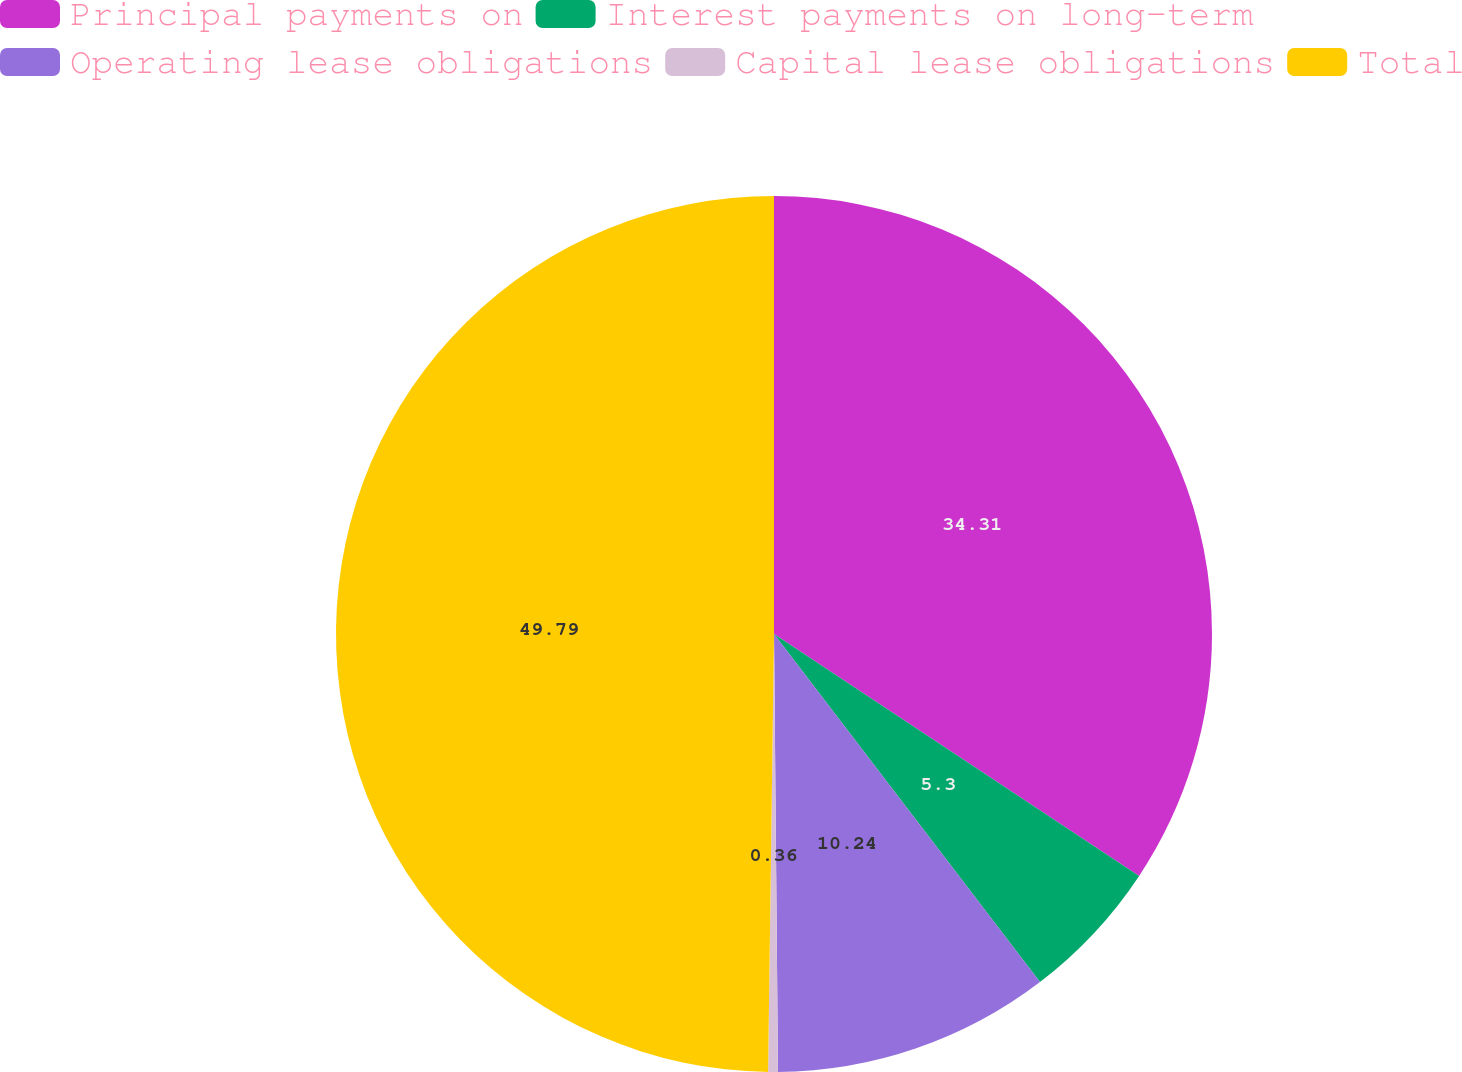Convert chart. <chart><loc_0><loc_0><loc_500><loc_500><pie_chart><fcel>Principal payments on<fcel>Interest payments on long-term<fcel>Operating lease obligations<fcel>Capital lease obligations<fcel>Total<nl><fcel>34.31%<fcel>5.3%<fcel>10.24%<fcel>0.36%<fcel>49.78%<nl></chart> 